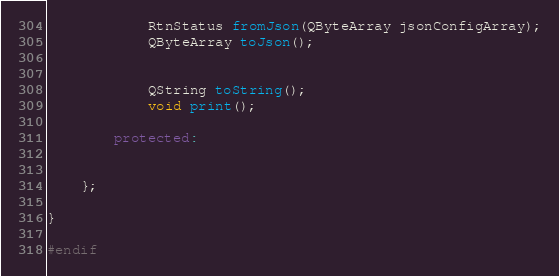<code> <loc_0><loc_0><loc_500><loc_500><_C++_>
            RtnStatus fromJson(QByteArray jsonConfigArray);
            QByteArray toJson();


            QString toString();
            void print();

        protected:

    
    };

}

#endif
</code> 